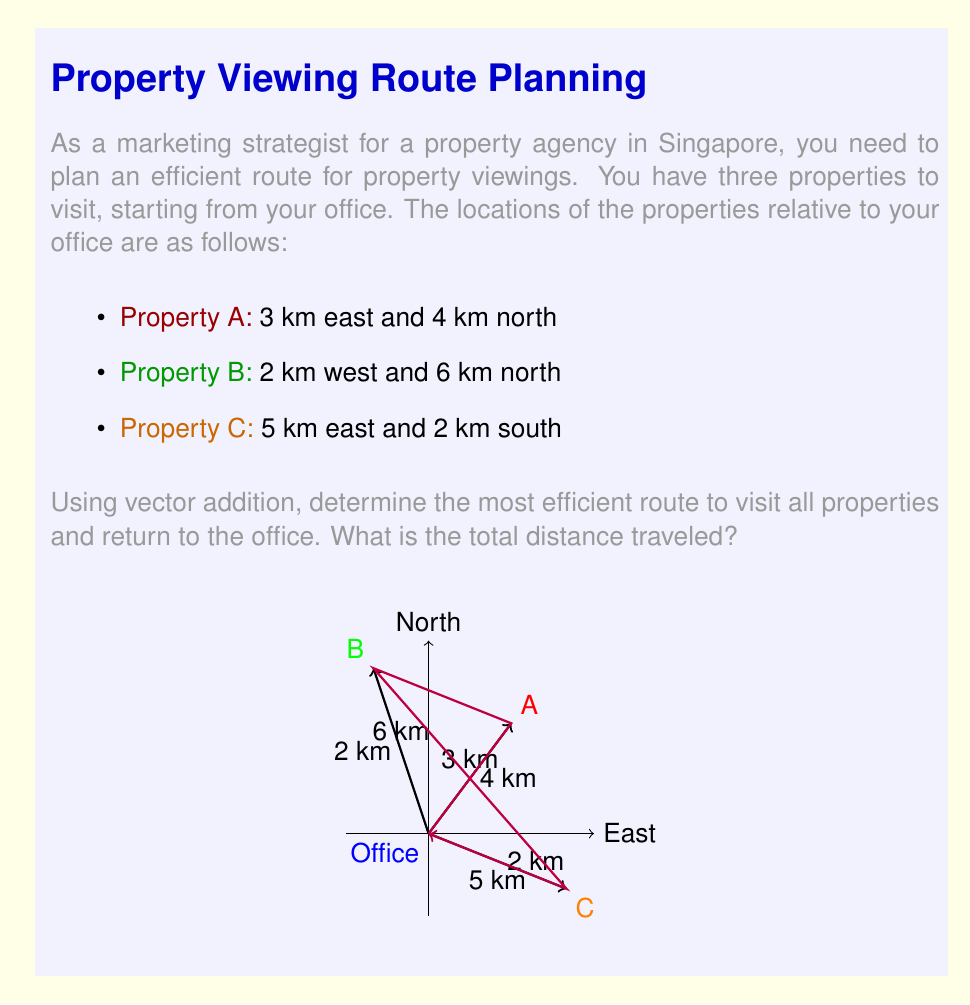Can you answer this question? Let's approach this step-by-step using vector addition:

1) First, let's define our vectors:
   $\vec{OA} = 3\hat{i} + 4\hat{j}$
   $\vec{OB} = -2\hat{i} + 6\hat{j}$
   $\vec{OC} = 5\hat{i} - 2\hat{j}$

2) To find the most efficient route, we'll start at the office (O), visit A, then B, then C, and return to O.

3) Calculate the vectors between properties:
   $\vec{AB} = \vec{OB} - \vec{OA} = (-2\hat{i} + 6\hat{j}) - (3\hat{i} + 4\hat{j}) = -5\hat{i} + 2\hat{j}$
   $\vec{BC} = \vec{OC} - \vec{OB} = (5\hat{i} - 2\hat{j}) - (-2\hat{i} + 6\hat{j}) = 7\hat{i} - 8\hat{j}$

4) Now, let's calculate the distances:
   $|\vec{OA}| = \sqrt{3^2 + 4^2} = 5$ km
   $|\vec{AB}| = \sqrt{(-5)^2 + 2^2} = \sqrt{29}$ km
   $|\vec{BC}| = \sqrt{7^2 + (-8)^2} = \sqrt{113}$ km
   $|\vec{CO}| = |\vec{OC}| = \sqrt{5^2 + (-2)^2} = \sqrt{29}$ km

5) The total distance is the sum of these magnitudes:
   Total distance = $5 + \sqrt{29} + \sqrt{113} + \sqrt{29}$ km

6) Simplifying:
   Total distance ≈ 5 + 5.39 + 10.63 + 5.39 = 26.41 km
Answer: 26.41 km 